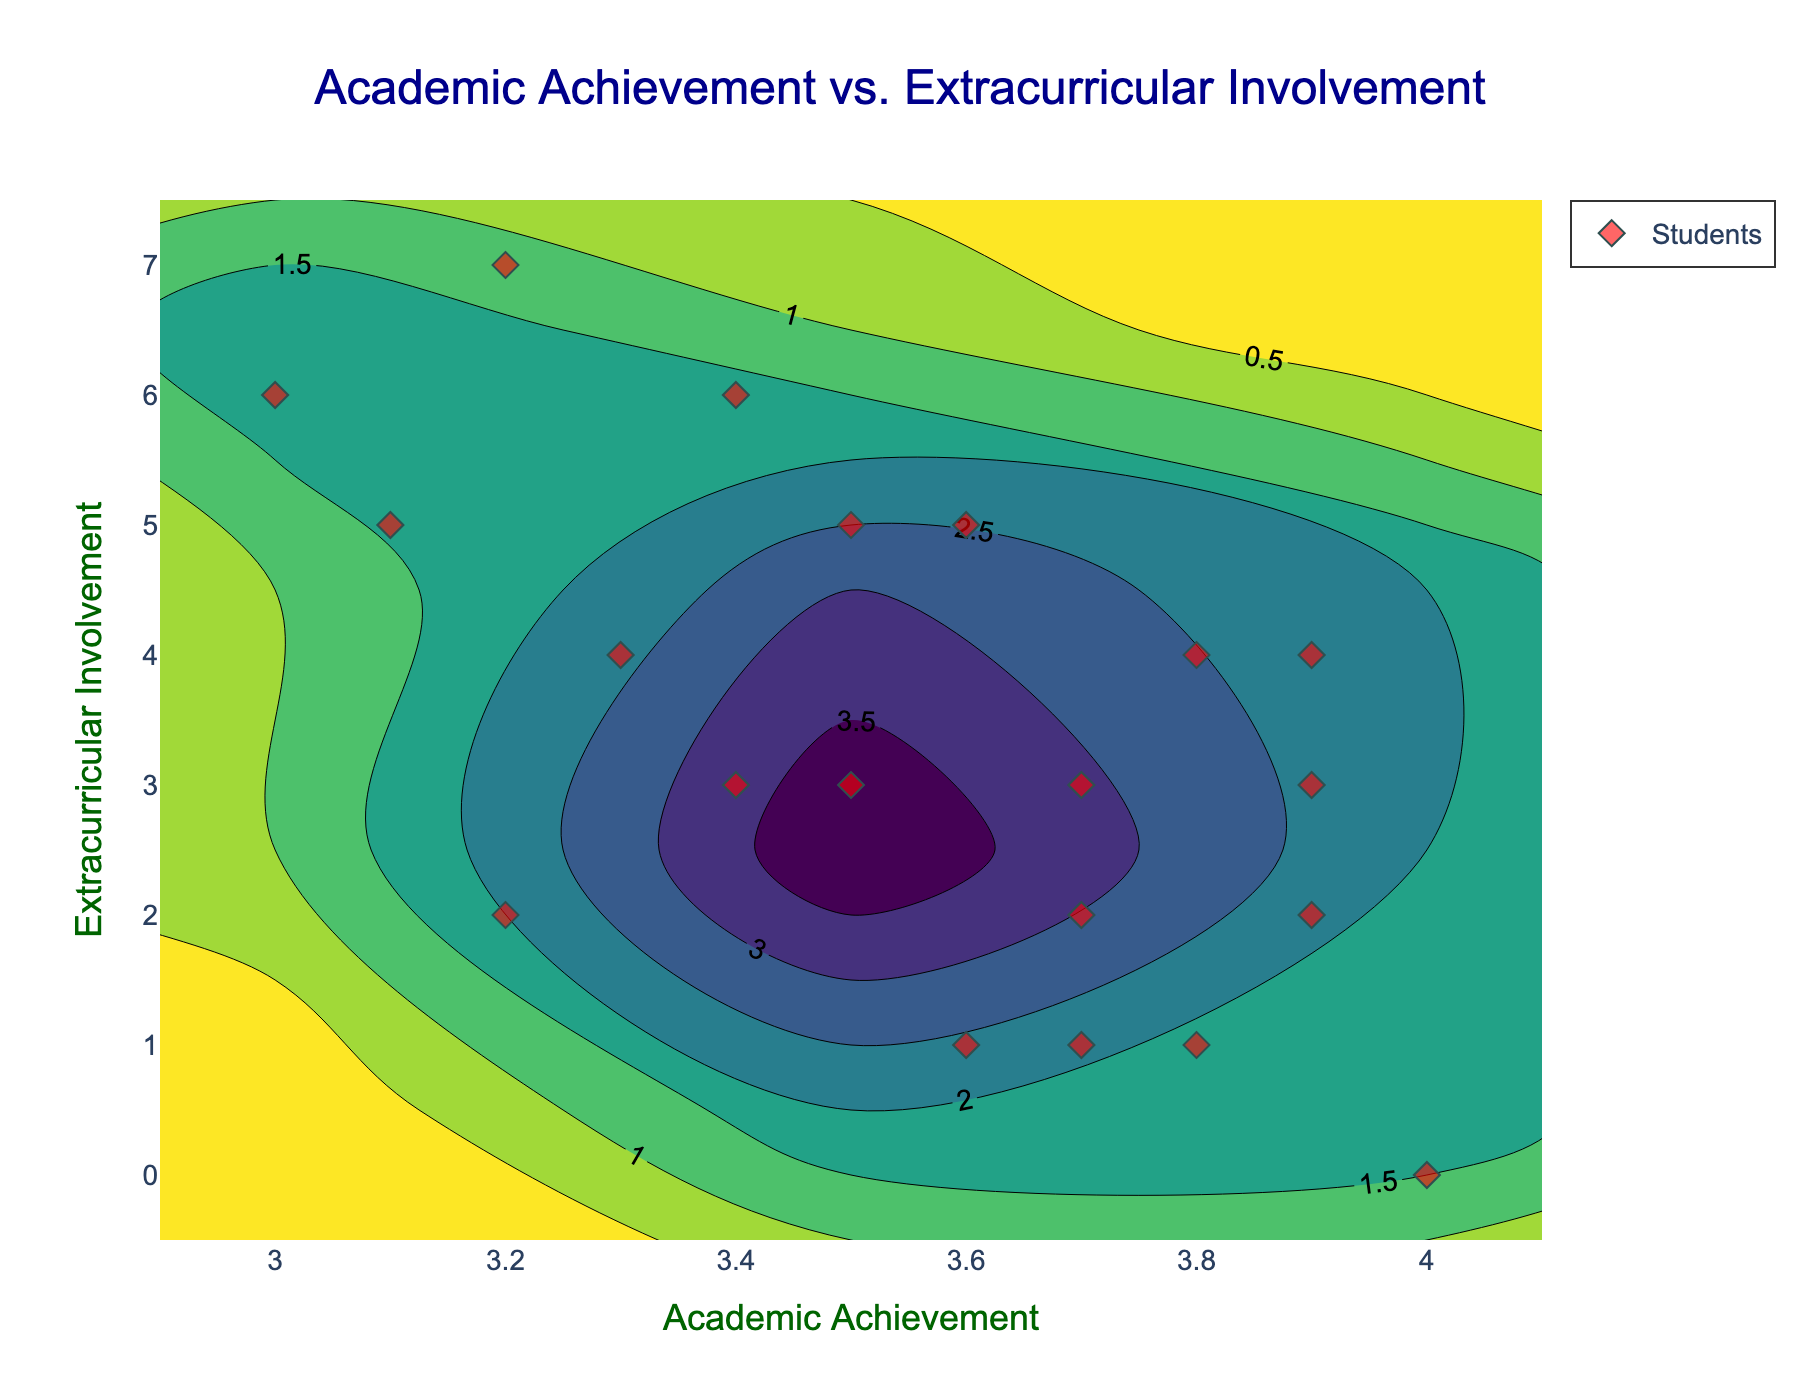What is the title of the plot? Look at the text at the top center of the plot.
Answer: Academic Achievement vs. Extracurricular Involvement What is the x-axis labeled as? Look at the label next to the horizontal axis.
Answer: Academic Achievement How many data points are there in the scatter plot? Count the number of diamond-shaped markers on the plot.
Answer: 20 What is the highest level of extracurricular involvement depicted in the plot? Check the maximum value on the y-axis that appears in the plot area.
Answer: 7 Where do most students fall in terms of academic achievement and extracurricular involvement? Observe the areas with the highest density indicated by darker colors.
Answer: Around 3.7 to 3.9 academic achievement and 3-4 extracurricular involvement Is there a student with a perfect academic achievement score? Look for a data point on the plot with an academic achievement level of 4.0.
Answer: Yes What general trend can you observe between academic achievement and extracurricular involvement? Analyze the density plot and scatter plot to identify any patterns or relationships between the two variables.
Answer: Students with lower extracurricular involvement tend to have higher academic achievement What is the difference in extracurricular involvement between the student with the highest academic achievement and the student with the lowest academic achievement? Find the values of extracurricular involvement for students with lowest (3.0) and highest (4.0) academic achievement levels, subtract the latter from the former.
Answer: 6 Are there more students involved in extracurricular activities more or less than the mean extracurricular involvement level? Identify the mean level by averaging out all extracurricular involvement values and count students on either side of this mean.
Answer: More students are below the mean Compare the number of students with academic achievement above 3.5 vs. those below 3.5. Count the number of points above and below the 3.5 academic achievement line on the x-axis.
Answer: More students have academic achievement above 3.5 